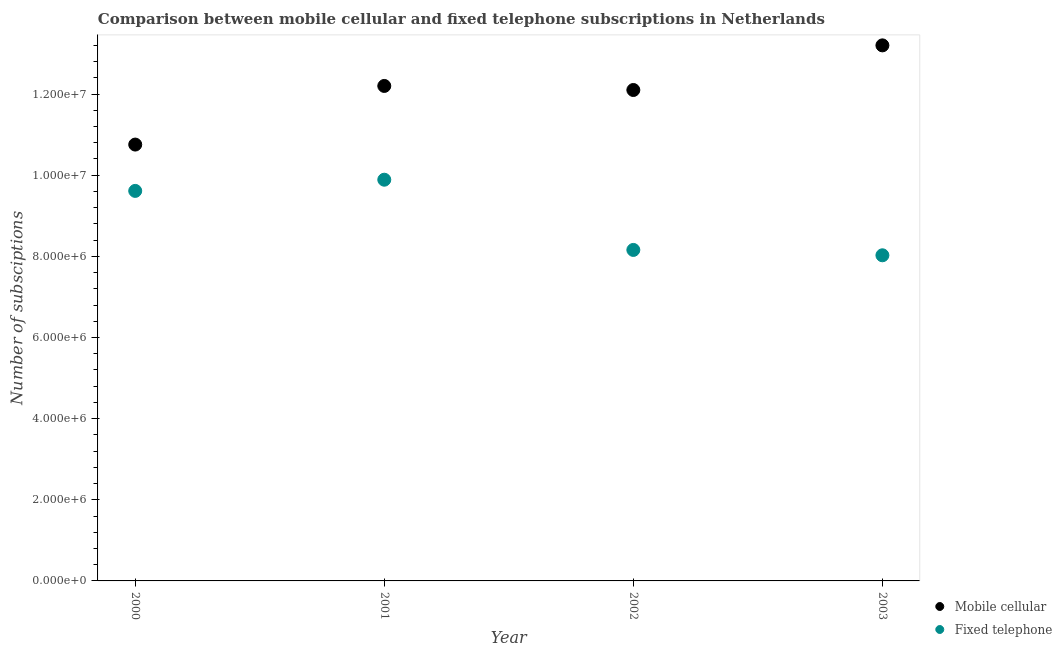How many different coloured dotlines are there?
Your response must be concise. 2. Is the number of dotlines equal to the number of legend labels?
Your answer should be very brief. Yes. What is the number of mobile cellular subscriptions in 2001?
Offer a terse response. 1.22e+07. Across all years, what is the maximum number of fixed telephone subscriptions?
Your answer should be very brief. 9.89e+06. Across all years, what is the minimum number of fixed telephone subscriptions?
Make the answer very short. 8.03e+06. In which year was the number of mobile cellular subscriptions maximum?
Give a very brief answer. 2003. What is the total number of mobile cellular subscriptions in the graph?
Ensure brevity in your answer.  4.83e+07. What is the difference between the number of mobile cellular subscriptions in 2000 and that in 2003?
Provide a succinct answer. -2.44e+06. What is the difference between the number of mobile cellular subscriptions in 2003 and the number of fixed telephone subscriptions in 2002?
Your answer should be compact. 5.04e+06. What is the average number of mobile cellular subscriptions per year?
Ensure brevity in your answer.  1.21e+07. In the year 2001, what is the difference between the number of fixed telephone subscriptions and number of mobile cellular subscriptions?
Provide a succinct answer. -2.31e+06. What is the ratio of the number of fixed telephone subscriptions in 2001 to that in 2002?
Ensure brevity in your answer.  1.21. Is the number of fixed telephone subscriptions in 2000 less than that in 2001?
Offer a very short reply. Yes. What is the difference between the highest and the second highest number of fixed telephone subscriptions?
Ensure brevity in your answer.  2.76e+05. What is the difference between the highest and the lowest number of mobile cellular subscriptions?
Ensure brevity in your answer.  2.44e+06. Is the number of mobile cellular subscriptions strictly greater than the number of fixed telephone subscriptions over the years?
Provide a succinct answer. Yes. How many years are there in the graph?
Your answer should be very brief. 4. Does the graph contain any zero values?
Give a very brief answer. No. How are the legend labels stacked?
Ensure brevity in your answer.  Vertical. What is the title of the graph?
Make the answer very short. Comparison between mobile cellular and fixed telephone subscriptions in Netherlands. Does "Personal remittances" appear as one of the legend labels in the graph?
Provide a short and direct response. No. What is the label or title of the X-axis?
Keep it short and to the point. Year. What is the label or title of the Y-axis?
Your response must be concise. Number of subsciptions. What is the Number of subsciptions in Mobile cellular in 2000?
Provide a succinct answer. 1.08e+07. What is the Number of subsciptions in Fixed telephone in 2000?
Offer a terse response. 9.61e+06. What is the Number of subsciptions of Mobile cellular in 2001?
Ensure brevity in your answer.  1.22e+07. What is the Number of subsciptions of Fixed telephone in 2001?
Keep it short and to the point. 9.89e+06. What is the Number of subsciptions of Mobile cellular in 2002?
Your answer should be compact. 1.21e+07. What is the Number of subsciptions in Fixed telephone in 2002?
Provide a short and direct response. 8.16e+06. What is the Number of subsciptions of Mobile cellular in 2003?
Offer a terse response. 1.32e+07. What is the Number of subsciptions in Fixed telephone in 2003?
Your answer should be very brief. 8.03e+06. Across all years, what is the maximum Number of subsciptions of Mobile cellular?
Offer a very short reply. 1.32e+07. Across all years, what is the maximum Number of subsciptions in Fixed telephone?
Your answer should be compact. 9.89e+06. Across all years, what is the minimum Number of subsciptions of Mobile cellular?
Your answer should be very brief. 1.08e+07. Across all years, what is the minimum Number of subsciptions of Fixed telephone?
Your answer should be compact. 8.03e+06. What is the total Number of subsciptions in Mobile cellular in the graph?
Your response must be concise. 4.83e+07. What is the total Number of subsciptions of Fixed telephone in the graph?
Provide a short and direct response. 3.57e+07. What is the difference between the Number of subsciptions in Mobile cellular in 2000 and that in 2001?
Keep it short and to the point. -1.44e+06. What is the difference between the Number of subsciptions in Fixed telephone in 2000 and that in 2001?
Give a very brief answer. -2.76e+05. What is the difference between the Number of subsciptions of Mobile cellular in 2000 and that in 2002?
Ensure brevity in your answer.  -1.34e+06. What is the difference between the Number of subsciptions of Fixed telephone in 2000 and that in 2002?
Offer a terse response. 1.46e+06. What is the difference between the Number of subsciptions of Mobile cellular in 2000 and that in 2003?
Your response must be concise. -2.44e+06. What is the difference between the Number of subsciptions in Fixed telephone in 2000 and that in 2003?
Make the answer very short. 1.59e+06. What is the difference between the Number of subsciptions of Mobile cellular in 2001 and that in 2002?
Your answer should be very brief. 1.00e+05. What is the difference between the Number of subsciptions in Fixed telephone in 2001 and that in 2002?
Ensure brevity in your answer.  1.73e+06. What is the difference between the Number of subsciptions in Fixed telephone in 2001 and that in 2003?
Ensure brevity in your answer.  1.86e+06. What is the difference between the Number of subsciptions in Mobile cellular in 2002 and that in 2003?
Keep it short and to the point. -1.10e+06. What is the difference between the Number of subsciptions of Fixed telephone in 2002 and that in 2003?
Ensure brevity in your answer.  1.32e+05. What is the difference between the Number of subsciptions of Mobile cellular in 2000 and the Number of subsciptions of Fixed telephone in 2001?
Give a very brief answer. 8.66e+05. What is the difference between the Number of subsciptions in Mobile cellular in 2000 and the Number of subsciptions in Fixed telephone in 2002?
Your answer should be very brief. 2.60e+06. What is the difference between the Number of subsciptions in Mobile cellular in 2000 and the Number of subsciptions in Fixed telephone in 2003?
Keep it short and to the point. 2.73e+06. What is the difference between the Number of subsciptions of Mobile cellular in 2001 and the Number of subsciptions of Fixed telephone in 2002?
Provide a short and direct response. 4.04e+06. What is the difference between the Number of subsciptions of Mobile cellular in 2001 and the Number of subsciptions of Fixed telephone in 2003?
Offer a very short reply. 4.17e+06. What is the difference between the Number of subsciptions in Mobile cellular in 2002 and the Number of subsciptions in Fixed telephone in 2003?
Provide a succinct answer. 4.07e+06. What is the average Number of subsciptions in Mobile cellular per year?
Your answer should be very brief. 1.21e+07. What is the average Number of subsciptions of Fixed telephone per year?
Your answer should be very brief. 8.92e+06. In the year 2000, what is the difference between the Number of subsciptions in Mobile cellular and Number of subsciptions in Fixed telephone?
Your answer should be very brief. 1.14e+06. In the year 2001, what is the difference between the Number of subsciptions of Mobile cellular and Number of subsciptions of Fixed telephone?
Provide a succinct answer. 2.31e+06. In the year 2002, what is the difference between the Number of subsciptions in Mobile cellular and Number of subsciptions in Fixed telephone?
Your answer should be very brief. 3.94e+06. In the year 2003, what is the difference between the Number of subsciptions in Mobile cellular and Number of subsciptions in Fixed telephone?
Provide a succinct answer. 5.17e+06. What is the ratio of the Number of subsciptions of Mobile cellular in 2000 to that in 2001?
Offer a terse response. 0.88. What is the ratio of the Number of subsciptions of Fixed telephone in 2000 to that in 2001?
Keep it short and to the point. 0.97. What is the ratio of the Number of subsciptions in Mobile cellular in 2000 to that in 2002?
Your answer should be compact. 0.89. What is the ratio of the Number of subsciptions in Fixed telephone in 2000 to that in 2002?
Your response must be concise. 1.18. What is the ratio of the Number of subsciptions of Mobile cellular in 2000 to that in 2003?
Provide a succinct answer. 0.81. What is the ratio of the Number of subsciptions of Fixed telephone in 2000 to that in 2003?
Provide a short and direct response. 1.2. What is the ratio of the Number of subsciptions of Mobile cellular in 2001 to that in 2002?
Your response must be concise. 1.01. What is the ratio of the Number of subsciptions in Fixed telephone in 2001 to that in 2002?
Provide a short and direct response. 1.21. What is the ratio of the Number of subsciptions of Mobile cellular in 2001 to that in 2003?
Your answer should be very brief. 0.92. What is the ratio of the Number of subsciptions in Fixed telephone in 2001 to that in 2003?
Provide a short and direct response. 1.23. What is the ratio of the Number of subsciptions in Mobile cellular in 2002 to that in 2003?
Give a very brief answer. 0.92. What is the ratio of the Number of subsciptions in Fixed telephone in 2002 to that in 2003?
Ensure brevity in your answer.  1.02. What is the difference between the highest and the second highest Number of subsciptions in Mobile cellular?
Offer a very short reply. 1.00e+06. What is the difference between the highest and the second highest Number of subsciptions in Fixed telephone?
Provide a succinct answer. 2.76e+05. What is the difference between the highest and the lowest Number of subsciptions of Mobile cellular?
Your response must be concise. 2.44e+06. What is the difference between the highest and the lowest Number of subsciptions of Fixed telephone?
Offer a terse response. 1.86e+06. 